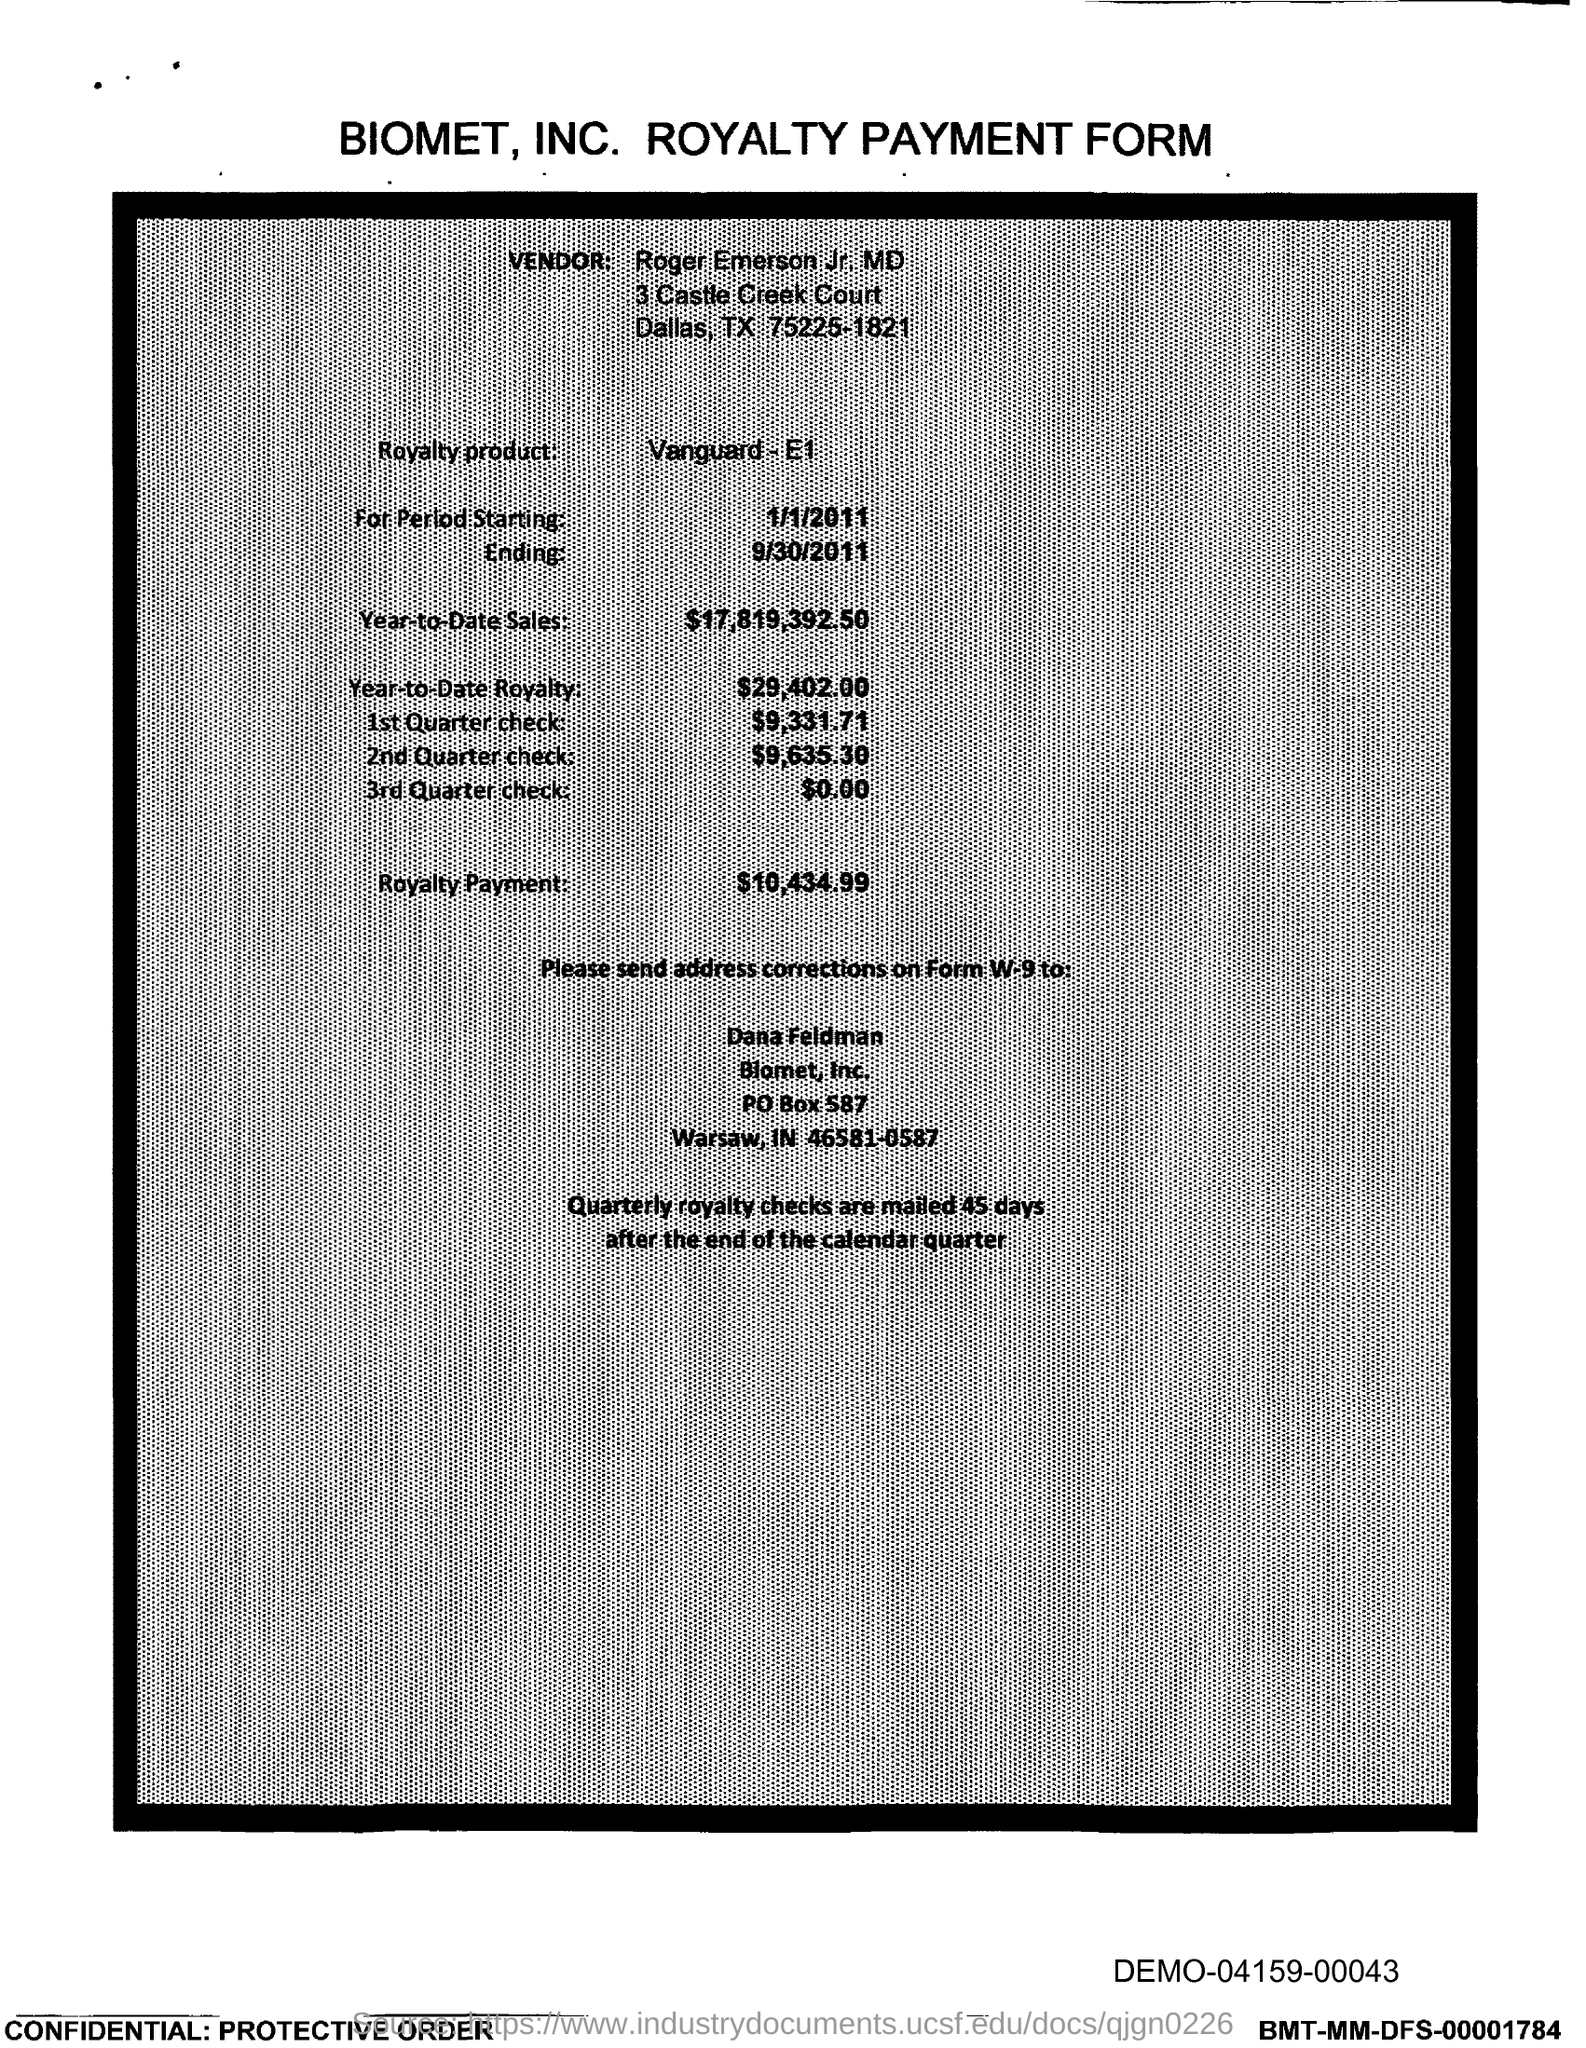Which company's royalty payment form is this?
Offer a very short reply. Biomet, Inc. Who is the vendor mentioned in the form?
Provide a succinct answer. Roger Emerson Jr. MD. What is the royalty product given in the form?
Your answer should be compact. Vanguard - E1. What is the Year-to-Date Sales of the royalty product?
Your response must be concise. $17,819,392.50. What is the Year-to-Date royalty of the product?
Keep it short and to the point. $29,402.00. What is the amount of 1st quarter check mentioned in the form?
Your answer should be compact. $9,331.71. What is the amount of 2nd Quarter check mentioned in the form?
Make the answer very short. $9,635.30. What is the amount of 3rd Quarter check given in the form?
Offer a terse response. $0.00. What is the royalty payment of the product mentioned in the form?
Make the answer very short. $10,434.99. 